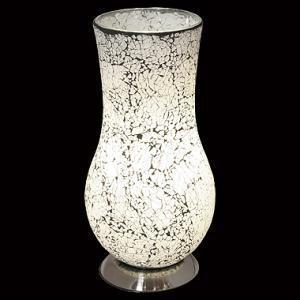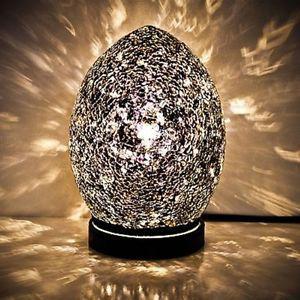The first image is the image on the left, the second image is the image on the right. Given the left and right images, does the statement "The right image shows a glowing egg shape on a black base, while the left image shows a vase with a flat, open top." hold true? Answer yes or no. Yes. The first image is the image on the left, the second image is the image on the right. Examine the images to the left and right. Is the description "there is a lamp shaped like an egg with the light reflecting on the wall and shiny surface it is sitting on, the base of the lamp is black and has a white line towards the top" accurate? Answer yes or no. Yes. 